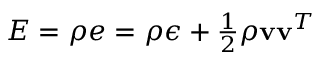Convert formula to latex. <formula><loc_0><loc_0><loc_500><loc_500>\begin{array} { r } { E = \rho e = \rho \epsilon + \frac { 1 } { 2 } \rho v v ^ { T } } \end{array}</formula> 